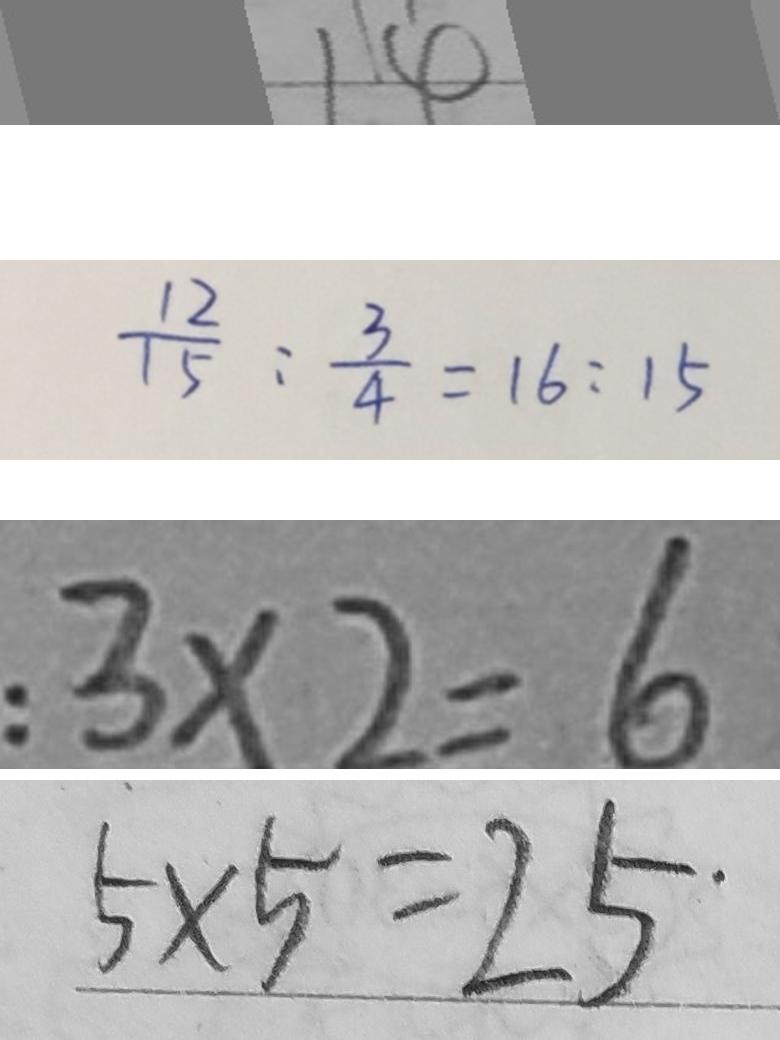Convert formula to latex. <formula><loc_0><loc_0><loc_500><loc_500>1 4 
 \frac { 1 2 } { 1 5 } : \frac { 3 } { 4 } = 1 6 : 1 5 
 : 3 \times 2 = 6 
 5 \times 5 = 2 5</formula> 